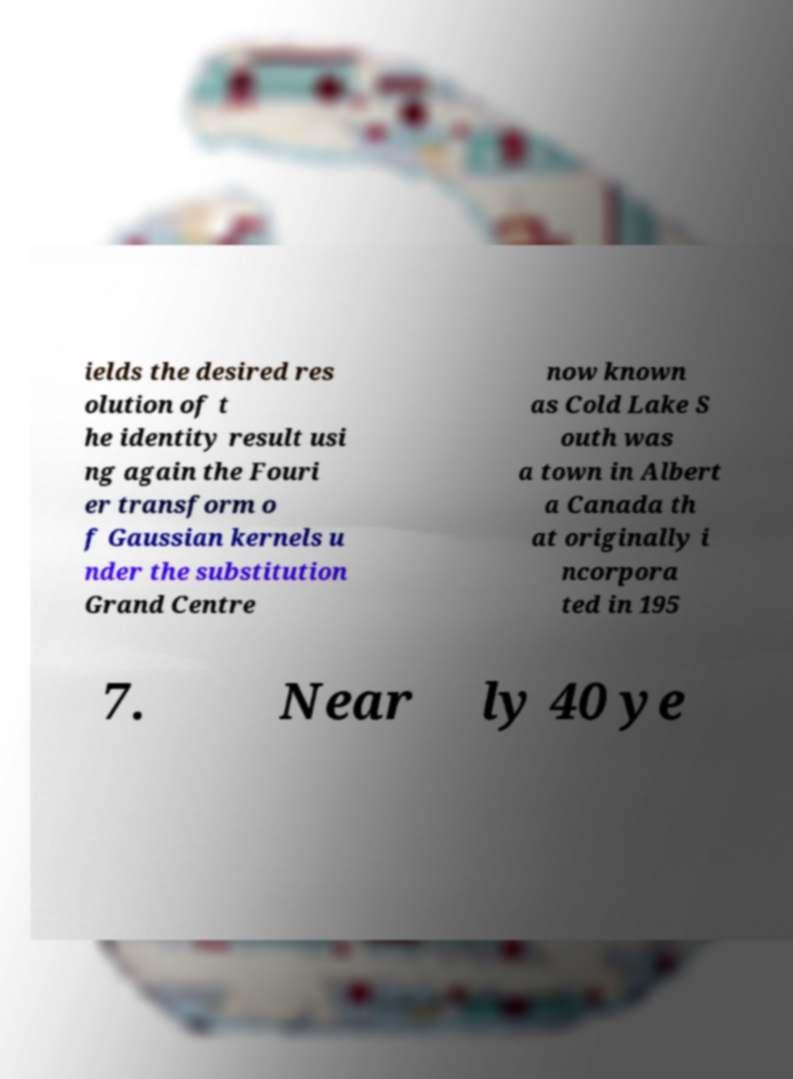Please read and relay the text visible in this image. What does it say? ields the desired res olution of t he identity result usi ng again the Fouri er transform o f Gaussian kernels u nder the substitution Grand Centre now known as Cold Lake S outh was a town in Albert a Canada th at originally i ncorpora ted in 195 7. Near ly 40 ye 